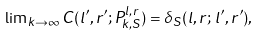Convert formula to latex. <formula><loc_0><loc_0><loc_500><loc_500>\lim \nolimits _ { k \to \infty } C ( l ^ { \prime } , r ^ { \prime } ; P _ { k , S } ^ { l , r } ) = \delta _ { S } ( l , r ; \, l ^ { \prime } , r ^ { \prime } ) ,</formula> 